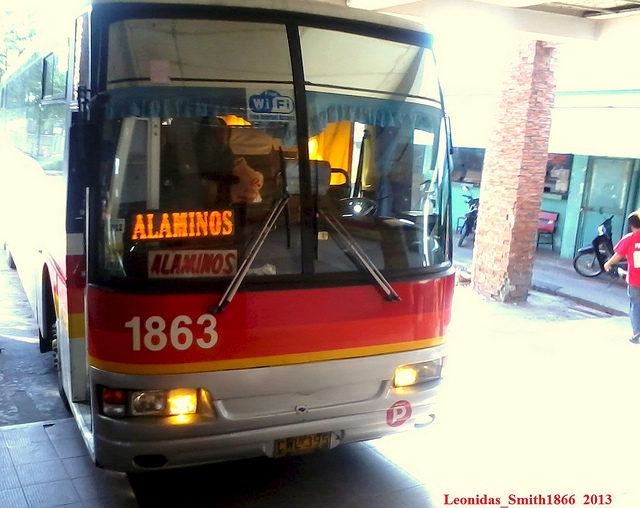What might the number '1863' indicate on the bus? The number '1863' on the bus likely represents the bus unit number or fleet number within the transportation company's inventory. This number helps the company track and manage its fleet, scheduling maintenance, and other operational tasks. It's also useful for passengers in the event they need to reference a specific bus, for example, when giving feedback or in lost and found situations. 